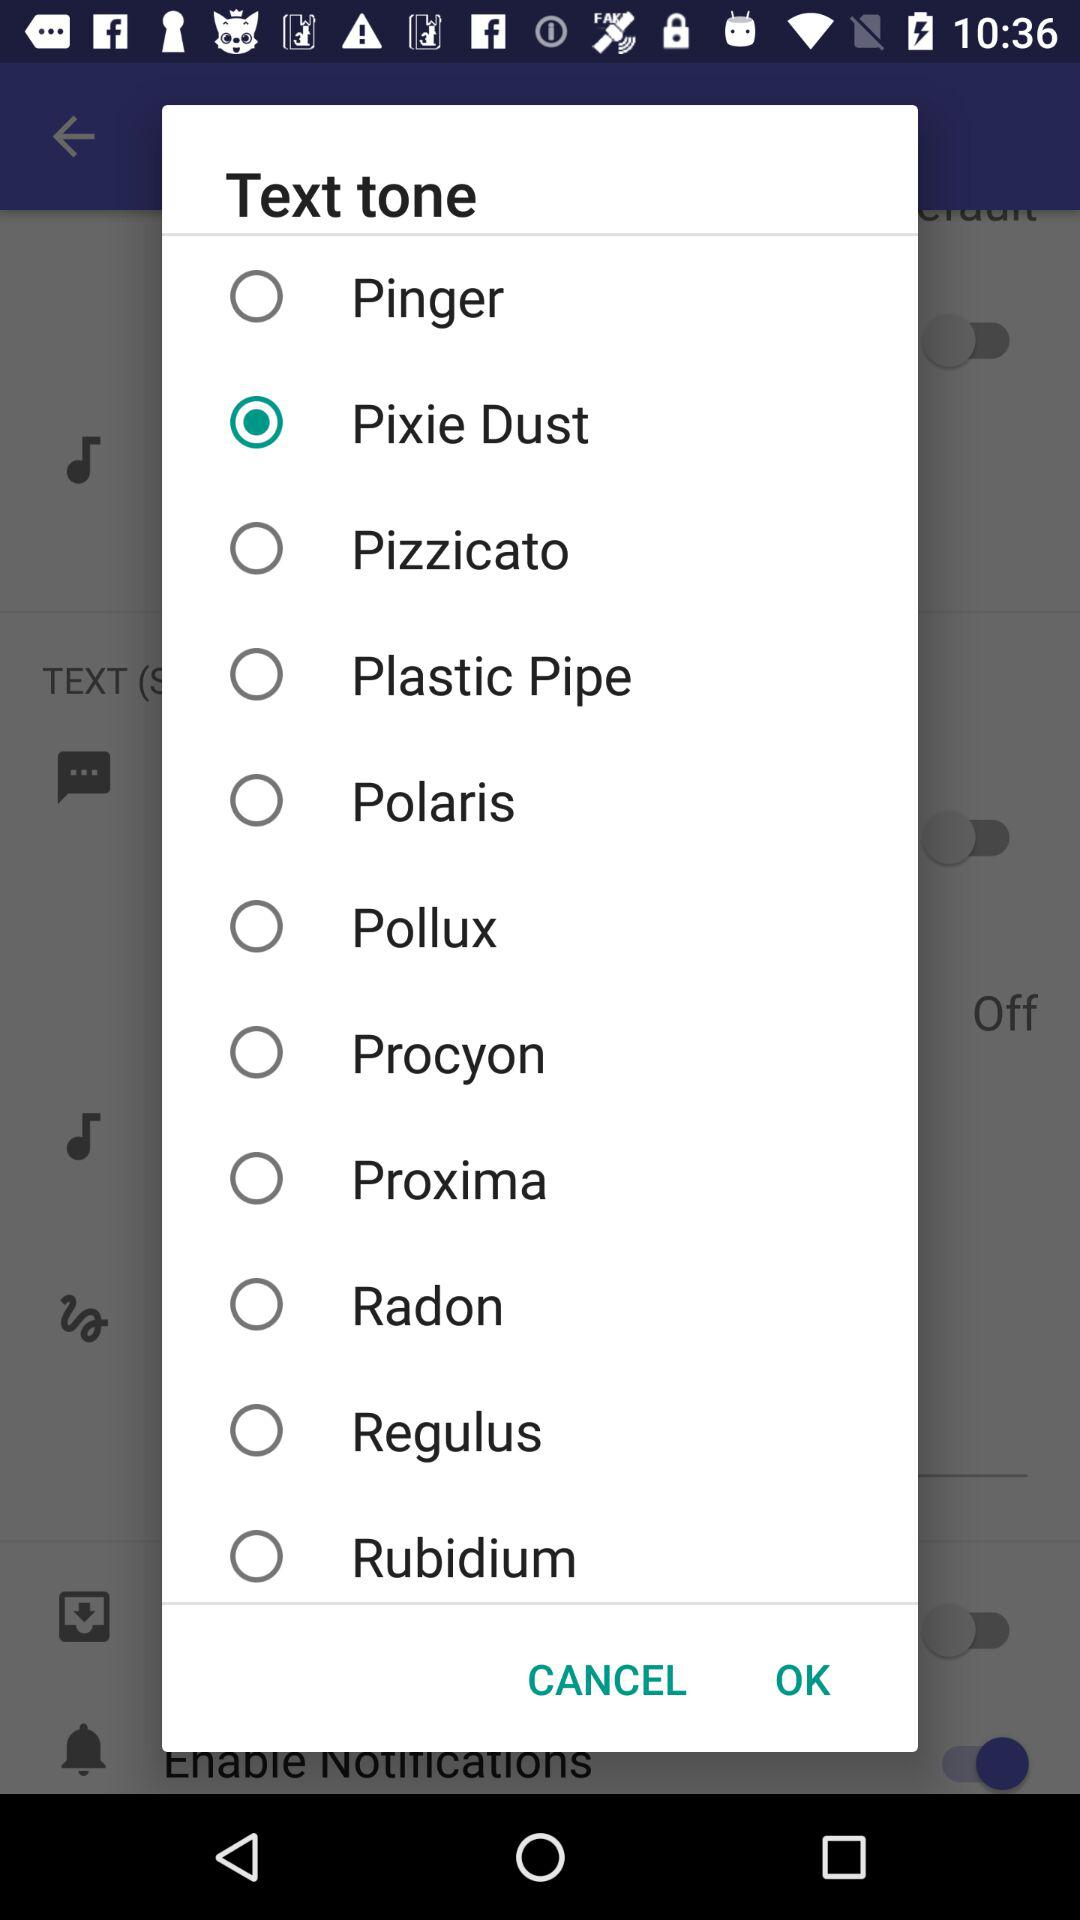Which text tone is selected on the application? The selected tone is Pixie Dust. 